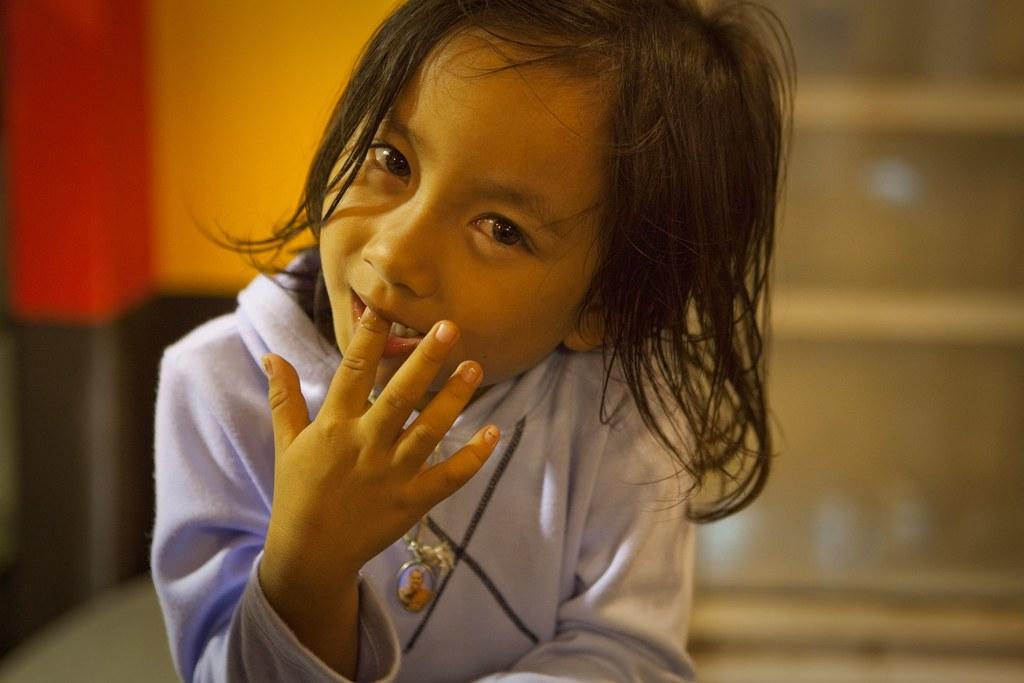What is the main subject of the image? There is a person in the image. Can you describe the background of the image? The background of the image is blurred. What type of gold award is the person holding in the image? There is no gold award present in the image; the person is the main subject. 